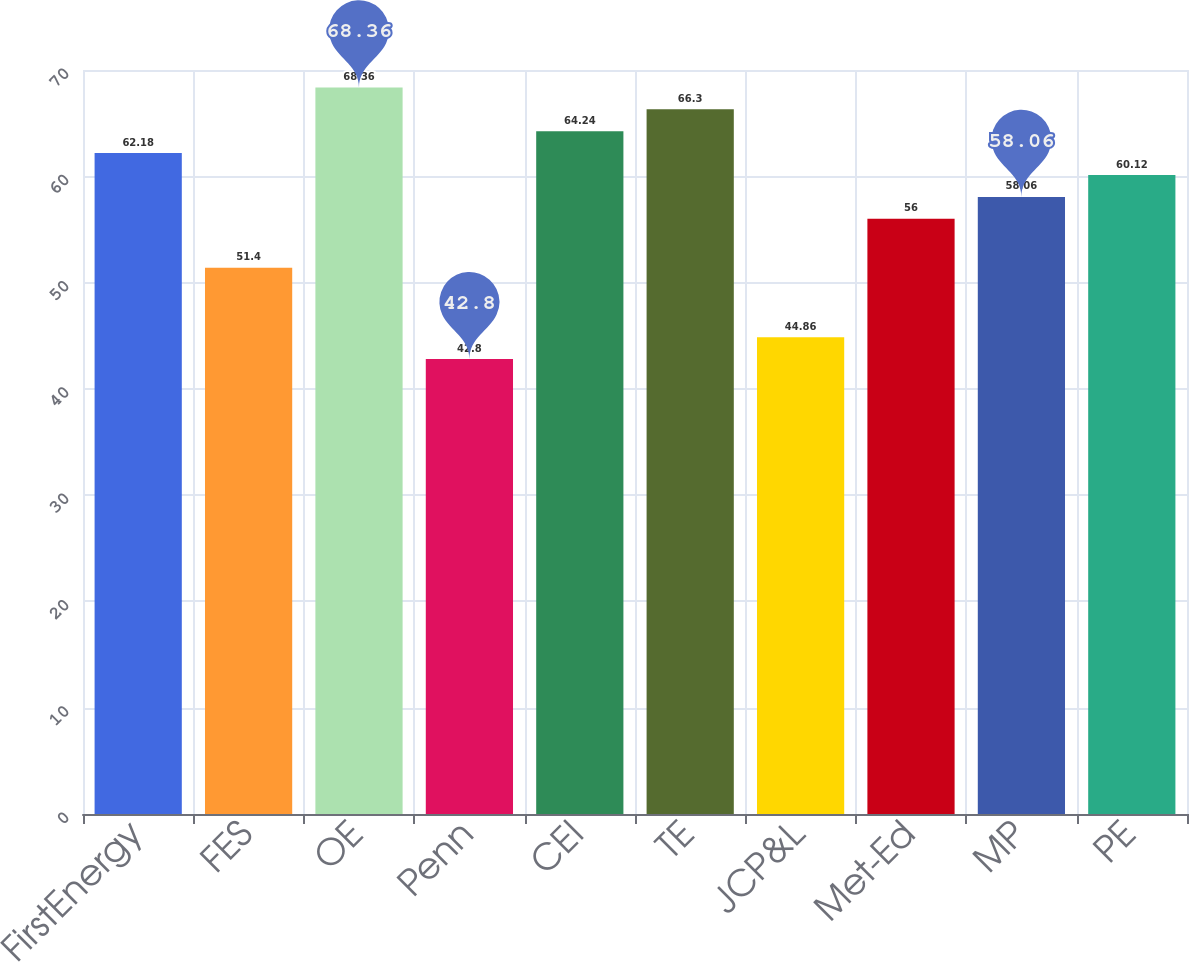Convert chart to OTSL. <chart><loc_0><loc_0><loc_500><loc_500><bar_chart><fcel>FirstEnergy<fcel>FES<fcel>OE<fcel>Penn<fcel>CEI<fcel>TE<fcel>JCP&L<fcel>Met-Ed<fcel>MP<fcel>PE<nl><fcel>62.18<fcel>51.4<fcel>68.36<fcel>42.8<fcel>64.24<fcel>66.3<fcel>44.86<fcel>56<fcel>58.06<fcel>60.12<nl></chart> 